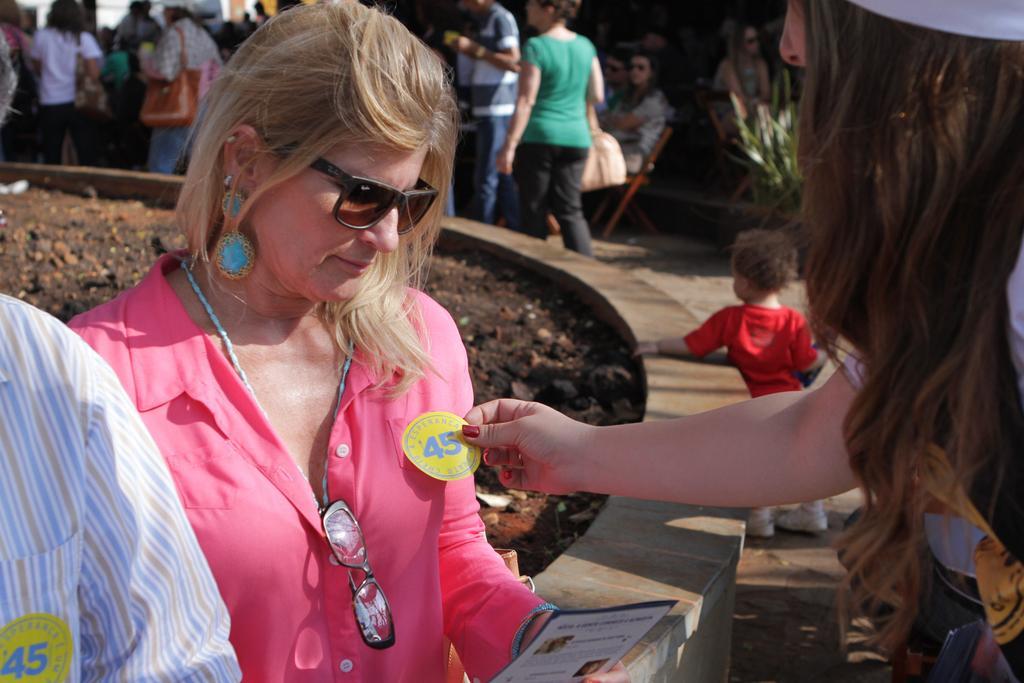Please provide a concise description of this image. On the left we can see a person and a woman is holding a paper in her hand. In the background there are few persons and among them few are carrying bags on their shoulders and we can also see few are sitting on the chairs. On the right we can see a kid standing on the ground and there is a woman standing. 